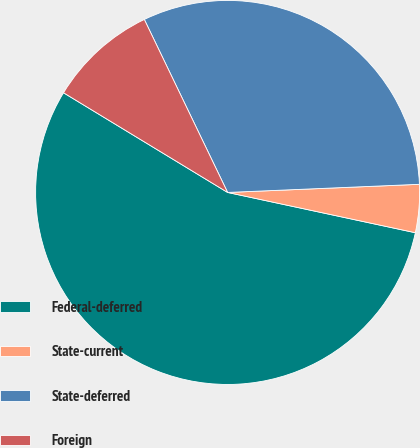Convert chart to OTSL. <chart><loc_0><loc_0><loc_500><loc_500><pie_chart><fcel>Federal-deferred<fcel>State-current<fcel>State-deferred<fcel>Foreign<nl><fcel>55.33%<fcel>4.04%<fcel>31.47%<fcel>9.17%<nl></chart> 